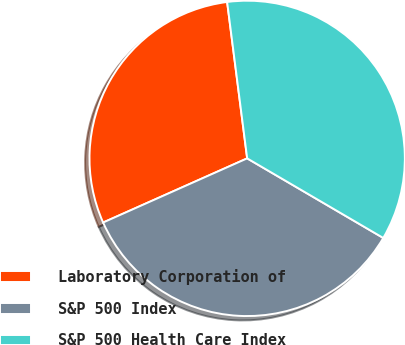<chart> <loc_0><loc_0><loc_500><loc_500><pie_chart><fcel>Laboratory Corporation of<fcel>S&P 500 Index<fcel>S&P 500 Health Care Index<nl><fcel>29.64%<fcel>34.91%<fcel>35.45%<nl></chart> 